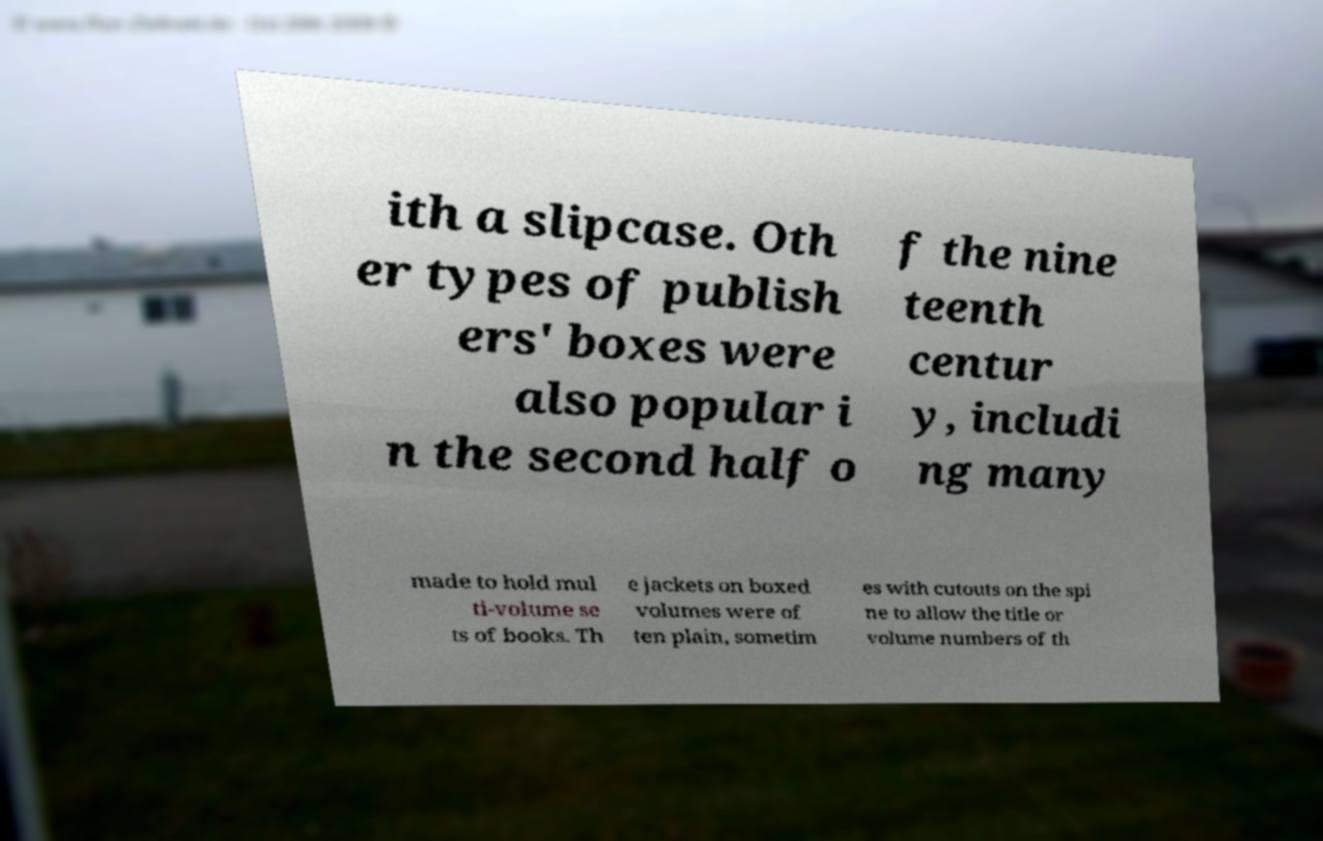For documentation purposes, I need the text within this image transcribed. Could you provide that? ith a slipcase. Oth er types of publish ers' boxes were also popular i n the second half o f the nine teenth centur y, includi ng many made to hold mul ti-volume se ts of books. Th e jackets on boxed volumes were of ten plain, sometim es with cutouts on the spi ne to allow the title or volume numbers of th 